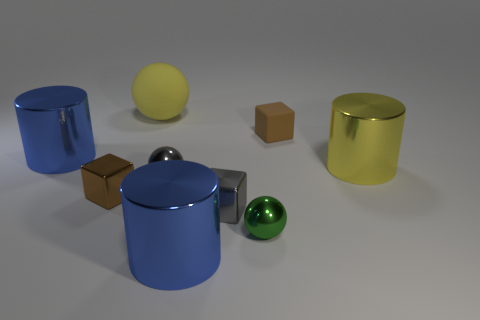What time of day does the lighting in this image suggest? The lighting in the image suggests an indoor setting with artificial lighting, likely not related to any specific time of day. The shadows are soft and diffused, indicating multiple light sources or a room with even lighting. 